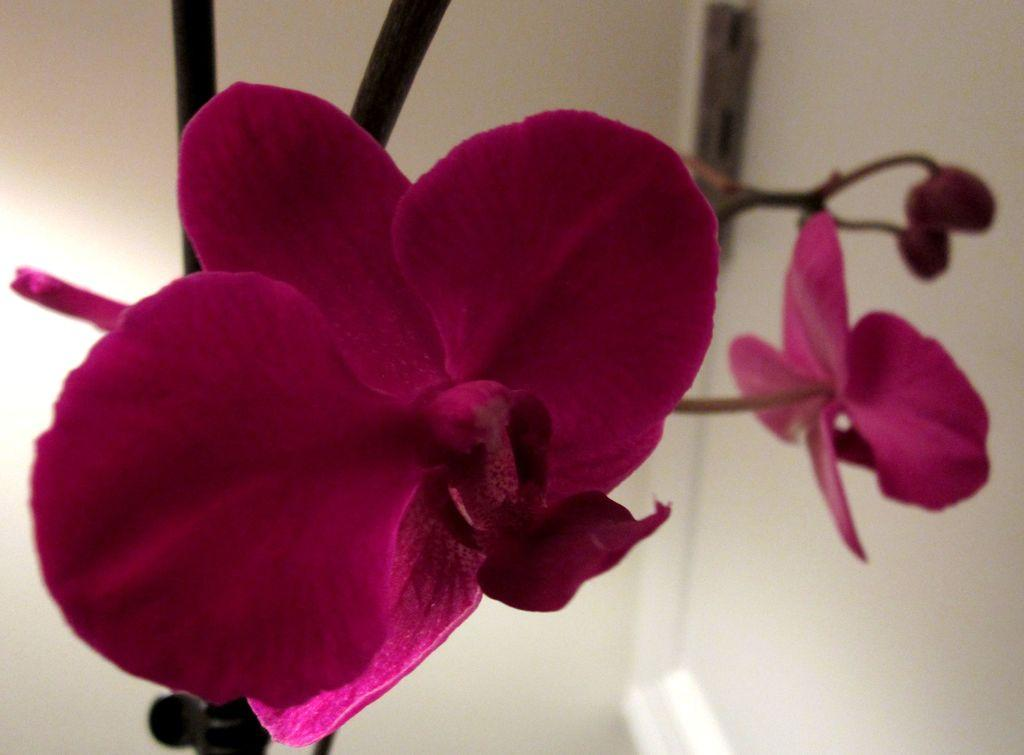What type of living organisms can be seen in the image? There are flowers in the image. What stage of growth are the flowers in the image? There are buds on the stems of a plant in the image, indicating that they are not fully bloomed yet. What type of polish is being applied to the chair in the image? There is no chair or polish present in the image; it only features flowers and buds on a plant. 